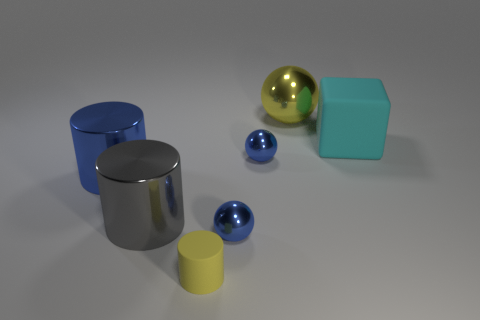What shape is the big yellow object?
Provide a short and direct response. Sphere. How many matte objects are the same color as the rubber block?
Provide a short and direct response. 0. There is another large shiny thing that is the same shape as the large blue shiny thing; what color is it?
Provide a short and direct response. Gray. What number of metallic balls are in front of the shiny sphere behind the cyan rubber cube?
Your answer should be very brief. 2. What number of blocks are either cyan things or gray objects?
Your response must be concise. 1. Is there a large brown object?
Make the answer very short. No. There is another metal object that is the same shape as the gray metal object; what is its size?
Make the answer very short. Large. There is a large metallic object right of the big cylinder that is in front of the large blue metallic cylinder; what is its shape?
Make the answer very short. Sphere. What number of gray things are big metal objects or metallic spheres?
Your answer should be compact. 1. The large cube has what color?
Offer a very short reply. Cyan. 